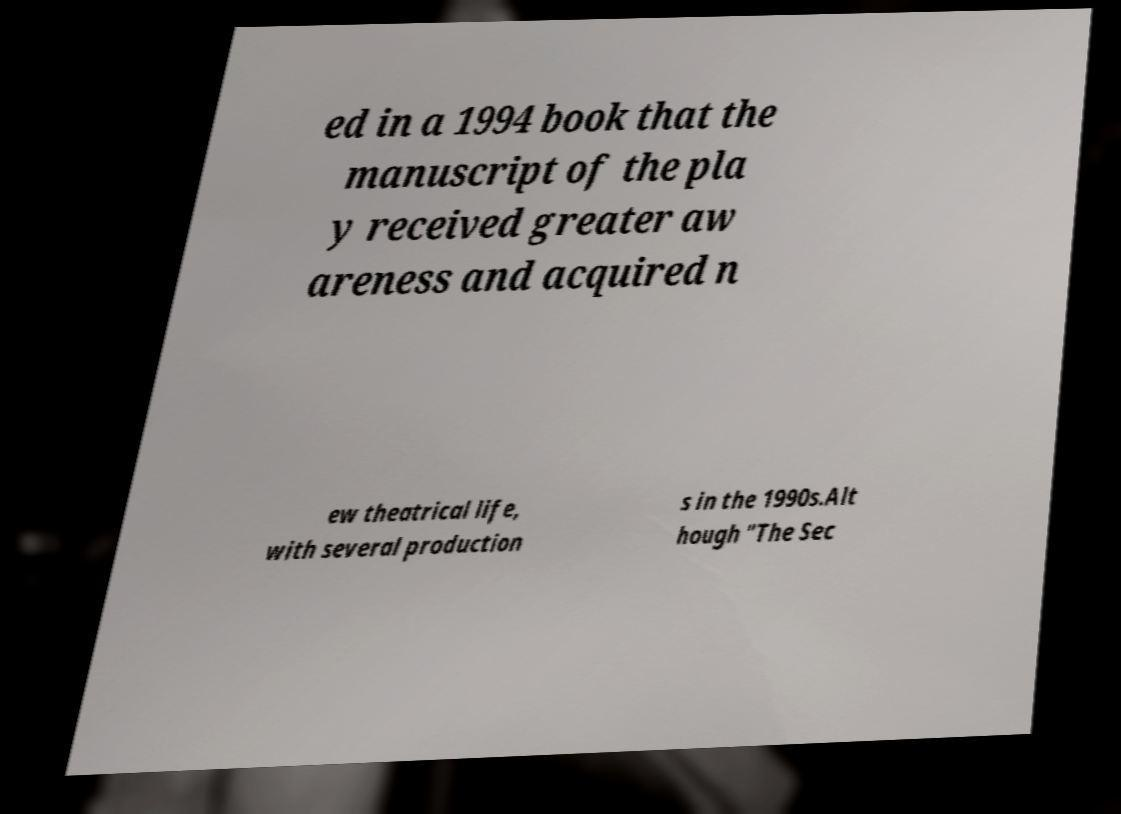There's text embedded in this image that I need extracted. Can you transcribe it verbatim? ed in a 1994 book that the manuscript of the pla y received greater aw areness and acquired n ew theatrical life, with several production s in the 1990s.Alt hough "The Sec 